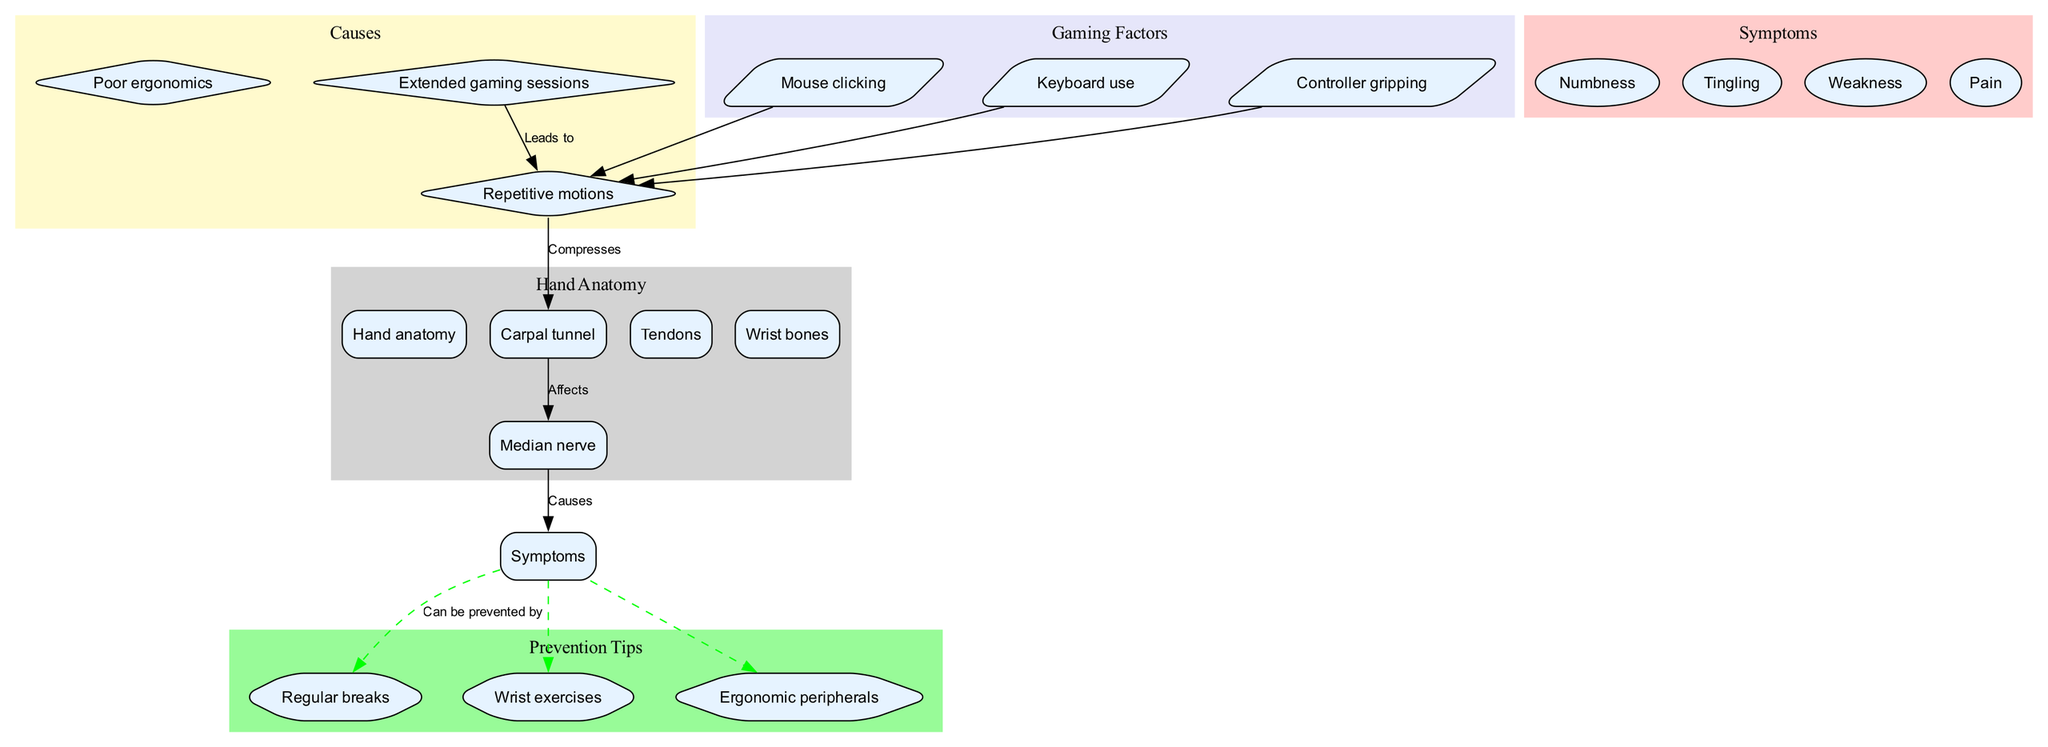What are the three main causes listed in the diagram? The diagram explicitly outlines three causes that lead to the effects described: "Repetitive motions," "Poor ergonomics," and "Extended gaming sessions." These causes are clearly indicated in the causes subgraph of the diagram.
Answer: Repetitive motions, Poor ergonomics, Extended gaming sessions How many symptoms are mentioned in the diagram? The diagram lists four symptoms related to the effects on hand and wrist anatomy, which are "Numbness," "Tingling," "Weakness," and "Pain." This count can be found by counting the nodes labeled as symptoms in the diagram.
Answer: 4 What does "Repetitive motions" compress? In the diagram, "Repetitive motions" is shown to compress the "Carpal tunnel," illustrating a direct relationship between the repetitive activity associated with gaming and the anatomical structure impacted.
Answer: Carpal tunnel Which prevention tip is connected to "Symptoms"? The diagram shows connections from "Symptoms" to several prevention tips. Specifically, one such prevention tip is "Regular breaks," which is indicated by a dashed line, suggesting a preventative action that can be taken against the symptoms mentioned.
Answer: Regular breaks What is the relationship between "Median nerve" and "Symptoms"? According to the diagram, the "Median nerve" directly causes the "Symptoms." This relationship is illustrated in the connections section of the diagram, highlighting the physiological impact of carpal tunnel syndrome on nerve functioning.
Answer: Causes How is "Extended gaming sessions" related to "Repetitive motions"? The diagram indicates a direct relationship where "Extended gaming sessions" lead to "Repetitive motions." This connection is crucial as it suggests that longer gaming periods increase the likelihood of repetitive hand and wrist movements.
Answer: Leads to What color represents "Prevention Tips" in the diagram? The diagram visually differentiates sections through color coding. "Prevention Tips" are represented using a light green shade, making it easily identifiable among other categories such as symptoms and causes.
Answer: Light green What type of shape represents "Tendons" in the anatomy subgraph? In the diagram, "Tendons" are typically represented using a rectangular box shape, in line with how other anatomical elements are depicted in the anatomy subgraph.
Answer: Box shape 